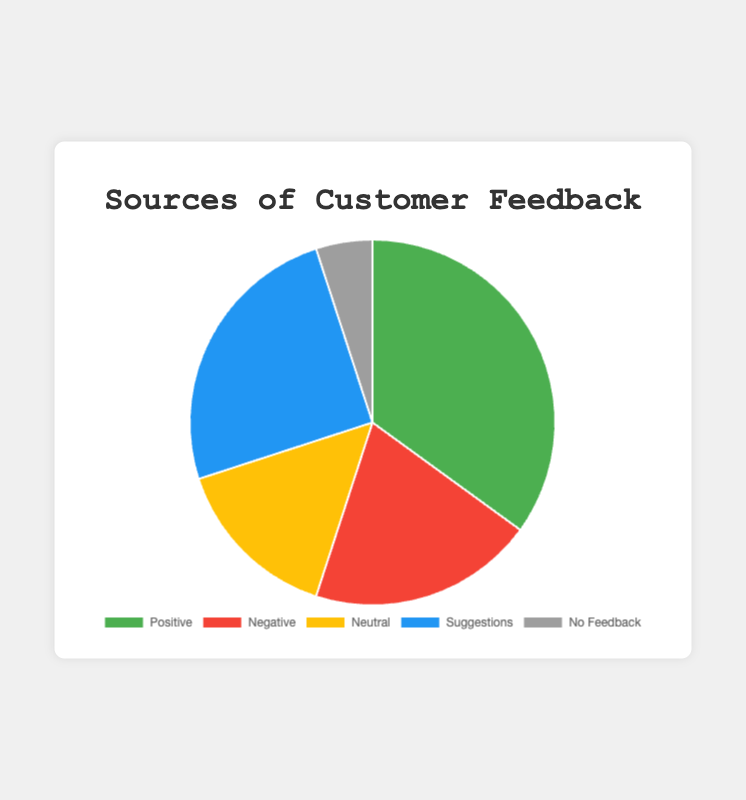Which feedback type has the highest percentage? The feedback type with the highest percentage is the one with the largest segment in the pie chart. This is marked with 'Positive' feedback at 35%.
Answer: Positive How much higher is the percentage of 'Positive' feedback compared to 'Negative' feedback? The percentage of 'Positive' feedback is 35%, and 'Negative' feedback is 20%. The difference is calculated as 35% - 20% = 15%.
Answer: 15% What is the combined percentage of 'Positive' and 'Suggestions' feedback types? The 'Positive' feedback is 35% and 'Suggestions' feedback is 25%. The combined percentage is 35% + 25% = 60%.
Answer: 60% Which feedback type has the smallest percentage? The smallest segment in the pie chart corresponds to 'No Feedback' at 5%.
Answer: No Feedback What is the difference between the percentage of 'Neutral' feedback and 'Negative' feedback? The percentage of 'Neutral' feedback is 15% and 'Negative' feedback is 20%. The difference is calculated as 20% - 15% = 5%.
Answer: 5% How does the 'Suggestions' feedback compare to 'Neutral' feedback, visually? The 'Suggestions' segment is larger than the 'Neutral' segment. 'Suggestions' has a percentage of 25%, while 'Neutral' has 15%, indicating that 'Suggestions' is more significant.
Answer: Suggestions > Neutral Calculate the average percentage of all feedback types. To find the average, sum all percentages and divide by the number of feedback types. The sum is 35% + 20% + 15% + 25% + 5% = 100%. The average is 100% / 5 = 20%.
Answer: 20% What proportion of the feedback types are 'Neutral' or 'No Feedback'? 'Neutral' feedback is 15% and 'No Feedback' is 5%. The combined proportion is 15% + 5% = 20%.
Answer: 20% If you combine 'Positive' and 'Negative' feedback, what fraction of the total feedback does this represent? 'Positive' feedback is 35% and 'Negative' feedback is 20%. Combined, they represent 35% + 20% = 55% of the total feedback. The fraction is 55/100, which simplifies to 11/20.
Answer: 11/20 What is the total percentage of feedback types excluding 'No Feedback'? Excluding 'No Feedback', the sum of other feedback types is 35% (Positive) + 20% (Negative) + 15% (Neutral) + 25% (Suggestions) = 95%.
Answer: 95% 